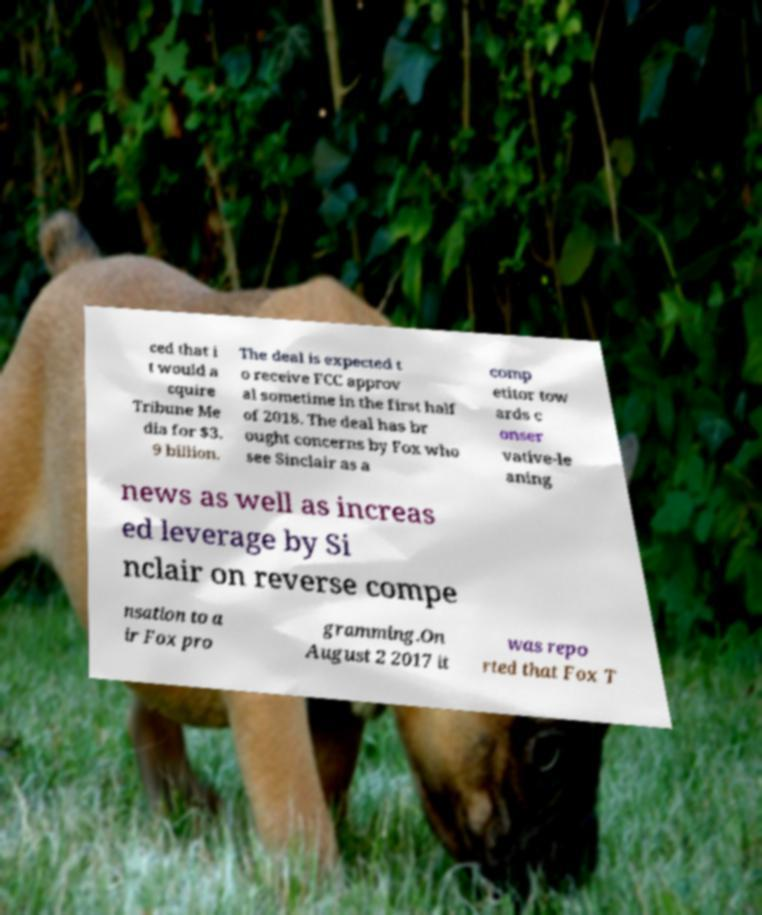Can you read and provide the text displayed in the image?This photo seems to have some interesting text. Can you extract and type it out for me? ced that i t would a cquire Tribune Me dia for $3. 9 billion. The deal is expected t o receive FCC approv al sometime in the first half of 2018. The deal has br ought concerns by Fox who see Sinclair as a comp etitor tow ards c onser vative-le aning news as well as increas ed leverage by Si nclair on reverse compe nsation to a ir Fox pro gramming.On August 2 2017 it was repo rted that Fox T 